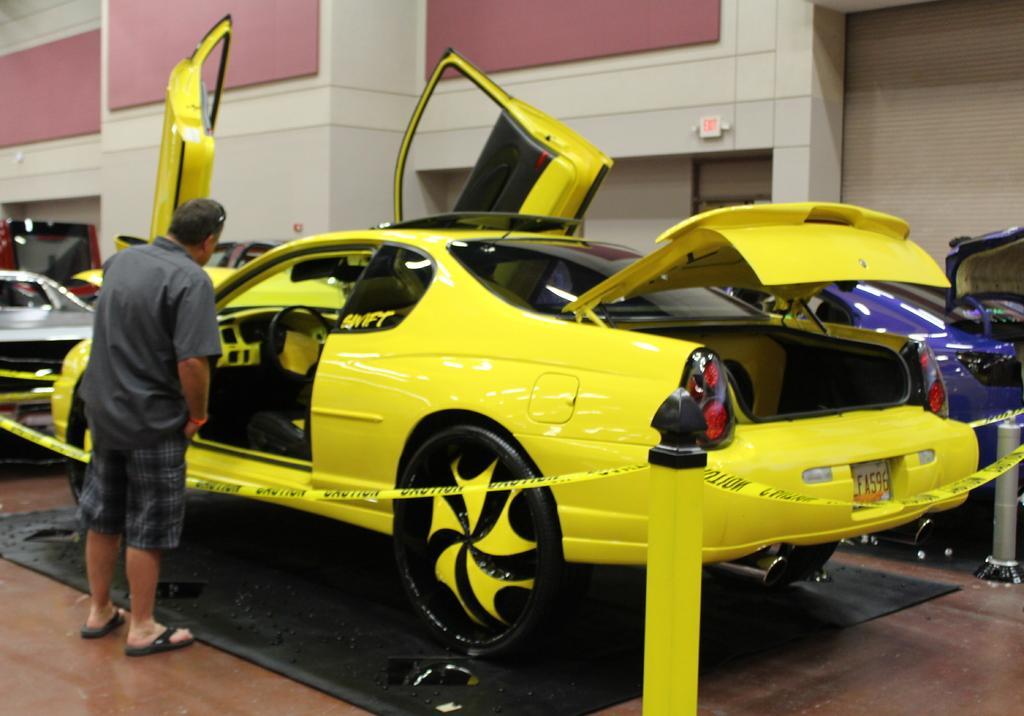How would you summarize this image in a sentence or two? Bottom right side of the image there is a fencing. Behind the fencing there are some vehicles. Bottom left side of the image a man is standing and watching. Top of the image there is a wall. 